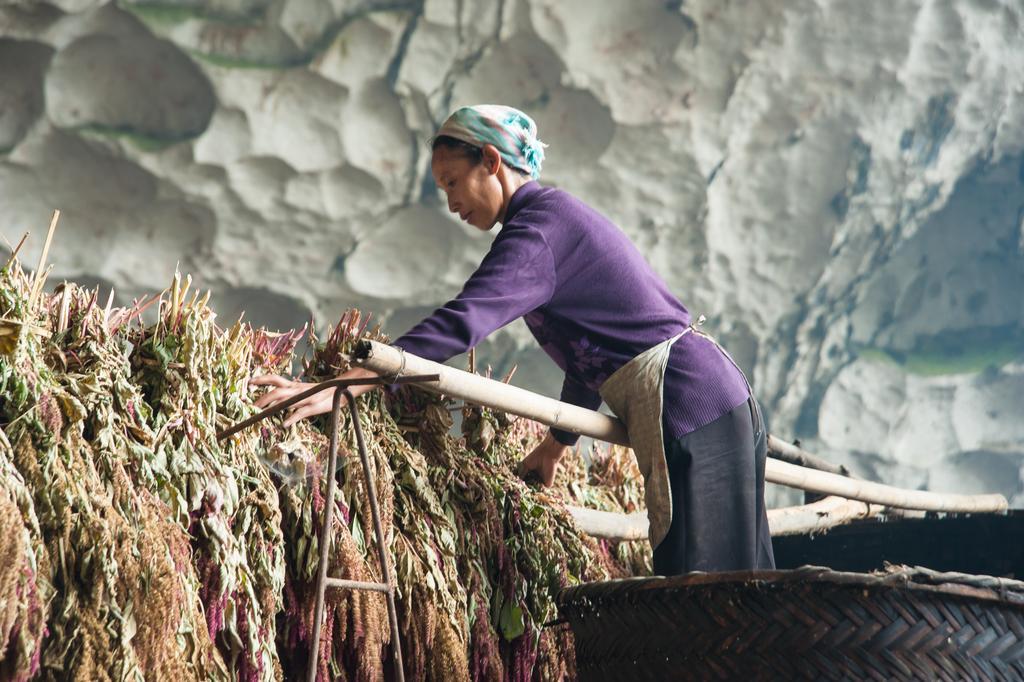In one or two sentences, can you explain what this image depicts? On the right side, there is a person with a violet color T-shirt, holding dry leaves which are on a wooden pole. Beside her, there is another wooden pole and this person is on a wooden object. In the background, there is a mountain. 